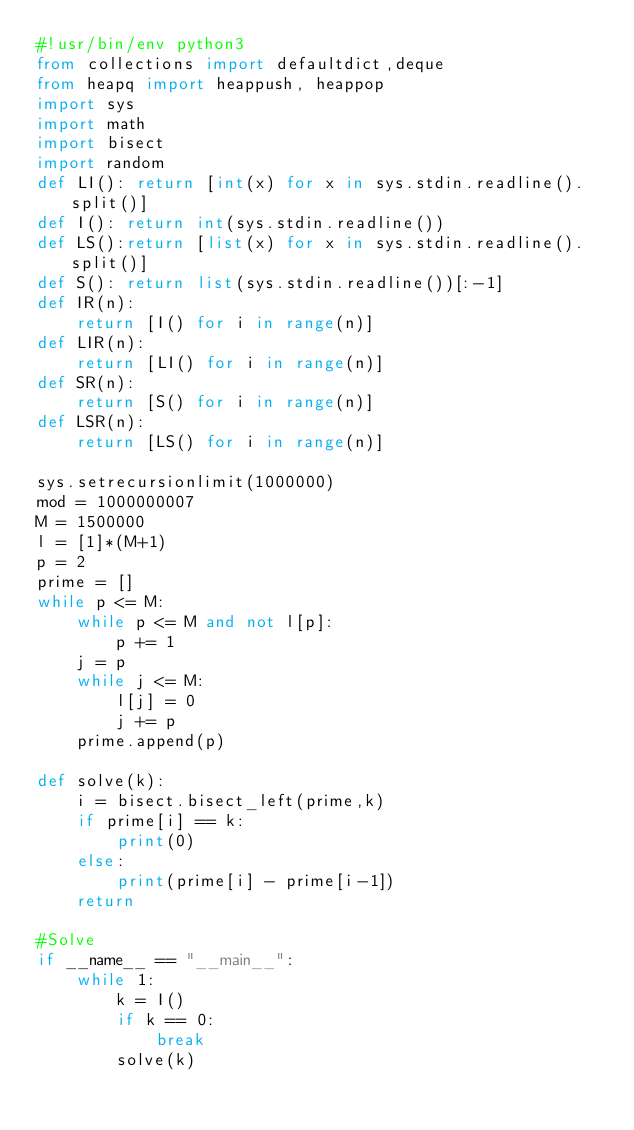Convert code to text. <code><loc_0><loc_0><loc_500><loc_500><_Python_>#!usr/bin/env python3
from collections import defaultdict,deque
from heapq import heappush, heappop
import sys
import math
import bisect
import random
def LI(): return [int(x) for x in sys.stdin.readline().split()]
def I(): return int(sys.stdin.readline())
def LS():return [list(x) for x in sys.stdin.readline().split()]
def S(): return list(sys.stdin.readline())[:-1]
def IR(n):
    return [I() for i in range(n)]
def LIR(n):
    return [LI() for i in range(n)]
def SR(n):
    return [S() for i in range(n)]
def LSR(n):
    return [LS() for i in range(n)]

sys.setrecursionlimit(1000000)
mod = 1000000007
M = 1500000
l = [1]*(M+1)
p = 2
prime = []
while p <= M:
    while p <= M and not l[p]:
        p += 1
    j = p
    while j <= M:
        l[j] = 0
        j += p
    prime.append(p)
    
def solve(k):
    i = bisect.bisect_left(prime,k)
    if prime[i] == k:
        print(0)
    else:
        print(prime[i] - prime[i-1])
    return

#Solve
if __name__ == "__main__":
    while 1:
        k = I()
        if k == 0:
            break
        solve(k)

</code> 